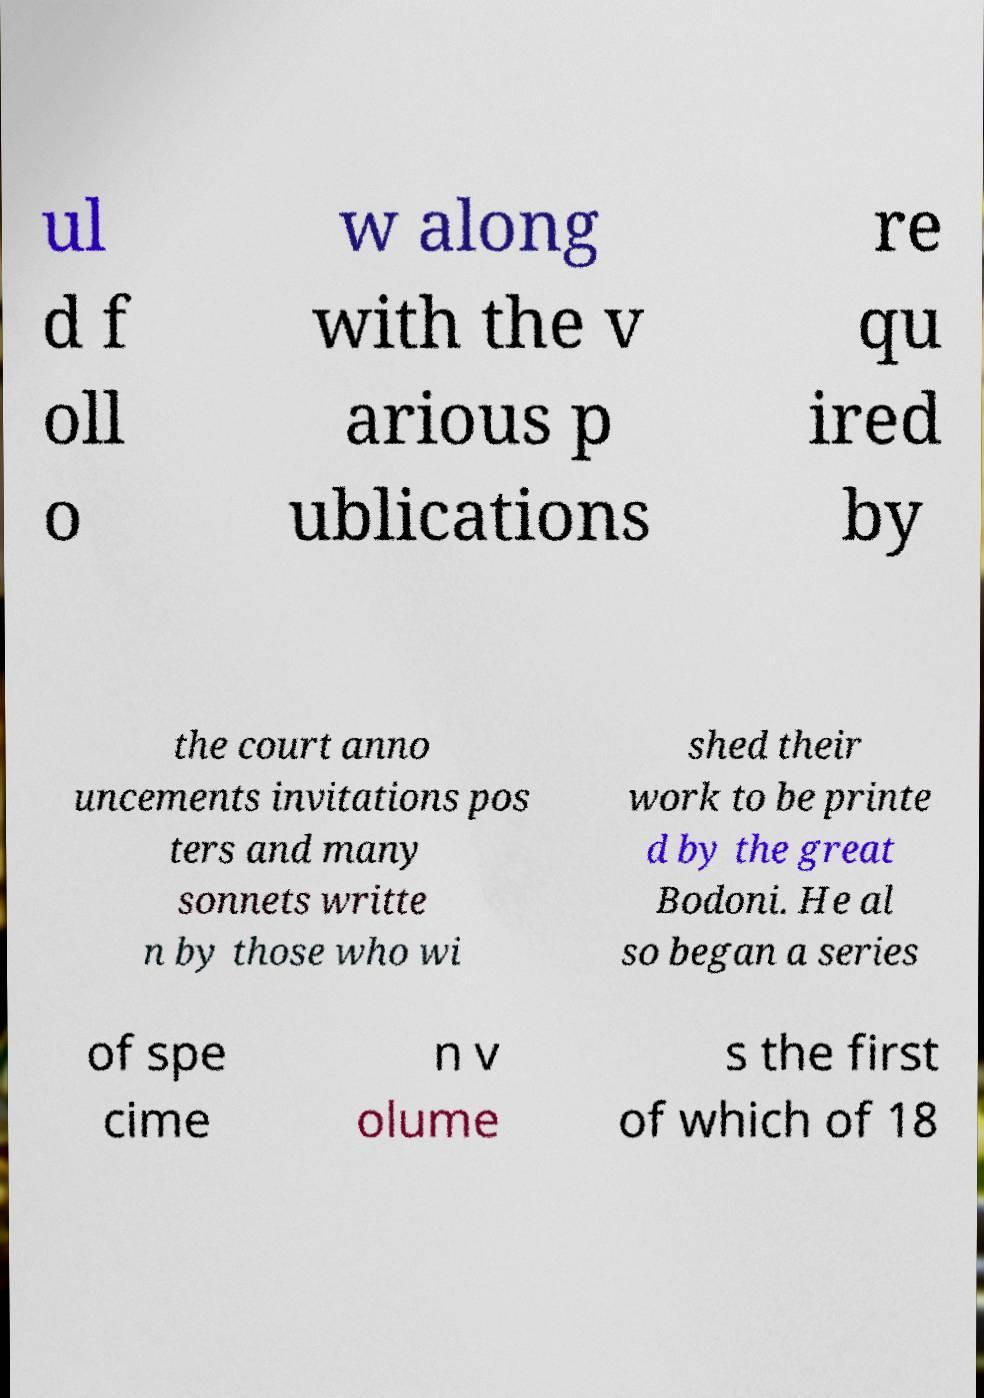Can you accurately transcribe the text from the provided image for me? ul d f oll o w along with the v arious p ublications re qu ired by the court anno uncements invitations pos ters and many sonnets writte n by those who wi shed their work to be printe d by the great Bodoni. He al so began a series of spe cime n v olume s the first of which of 18 